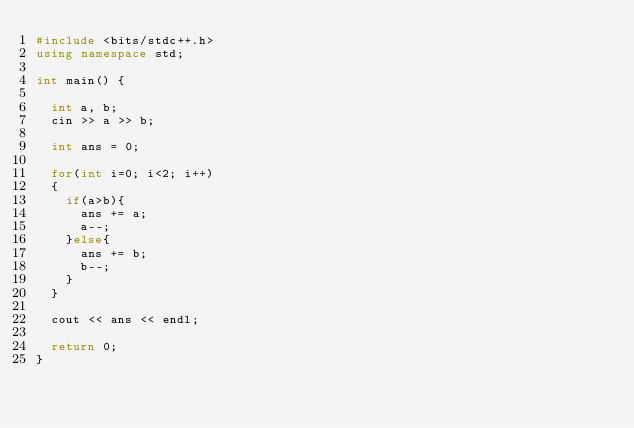<code> <loc_0><loc_0><loc_500><loc_500><_C++_>#include <bits/stdc++.h>
using namespace std;
  
int main() {

  int a, b;
  cin >> a >> b;
  
  int ans = 0;
  
  for(int i=0; i<2; i++)
  {
    if(a>b){
      ans += a;
      a--;
    }else{
      ans += b;
      b--;
    }
  }
  
  cout << ans << endl;
  
  return 0;
}</code> 